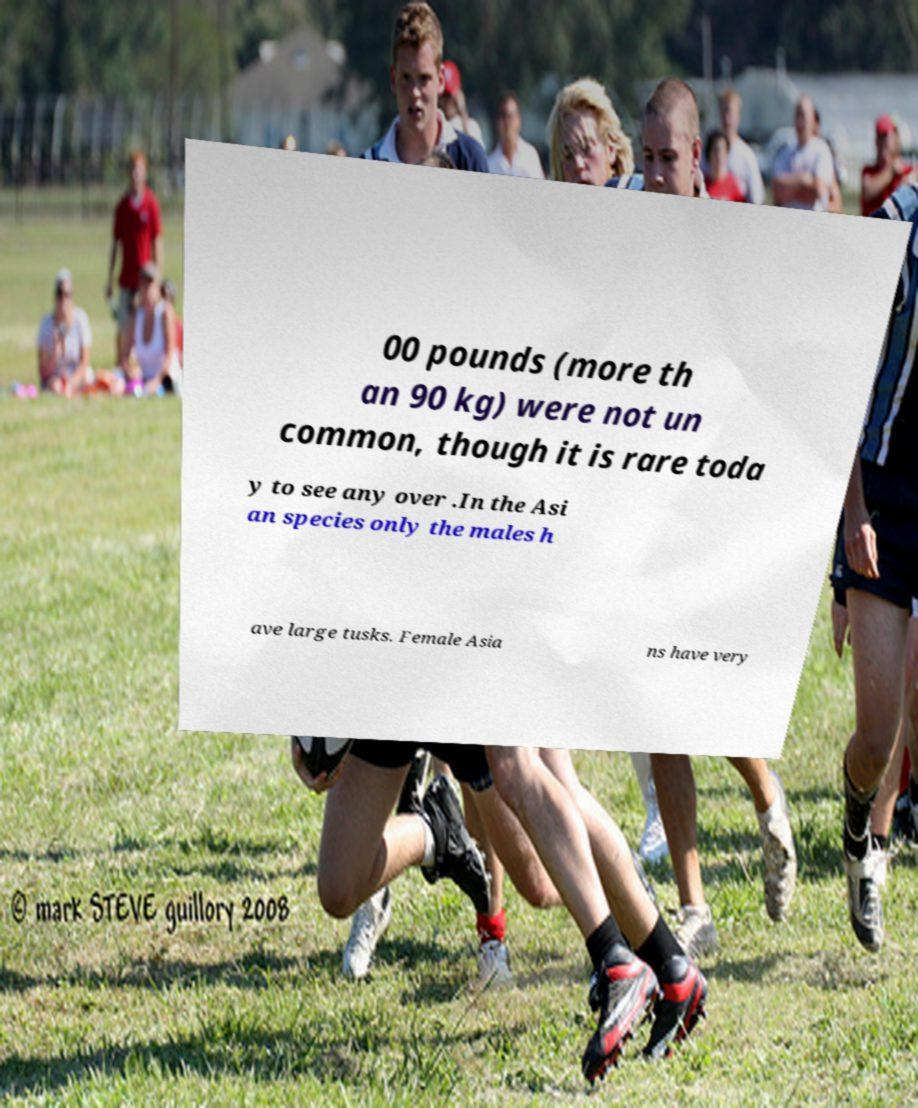I need the written content from this picture converted into text. Can you do that? 00 pounds (more th an 90 kg) were not un common, though it is rare toda y to see any over .In the Asi an species only the males h ave large tusks. Female Asia ns have very 